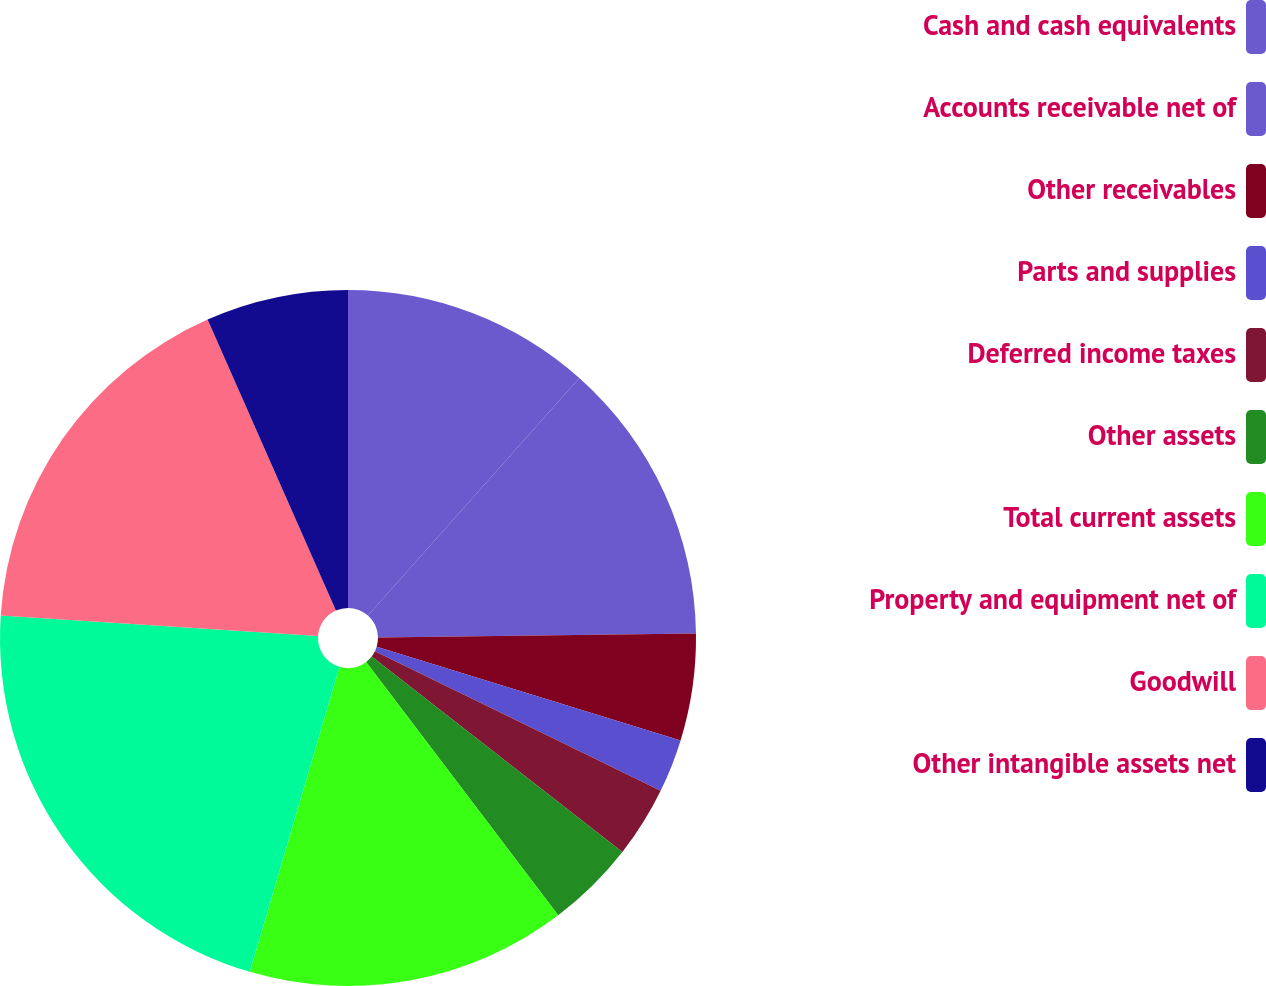Convert chart. <chart><loc_0><loc_0><loc_500><loc_500><pie_chart><fcel>Cash and cash equivalents<fcel>Accounts receivable net of<fcel>Other receivables<fcel>Parts and supplies<fcel>Deferred income taxes<fcel>Other assets<fcel>Total current assets<fcel>Property and equipment net of<fcel>Goodwill<fcel>Other intangible assets net<nl><fcel>11.57%<fcel>13.22%<fcel>4.96%<fcel>2.48%<fcel>3.31%<fcel>4.13%<fcel>14.87%<fcel>21.48%<fcel>17.35%<fcel>6.61%<nl></chart> 